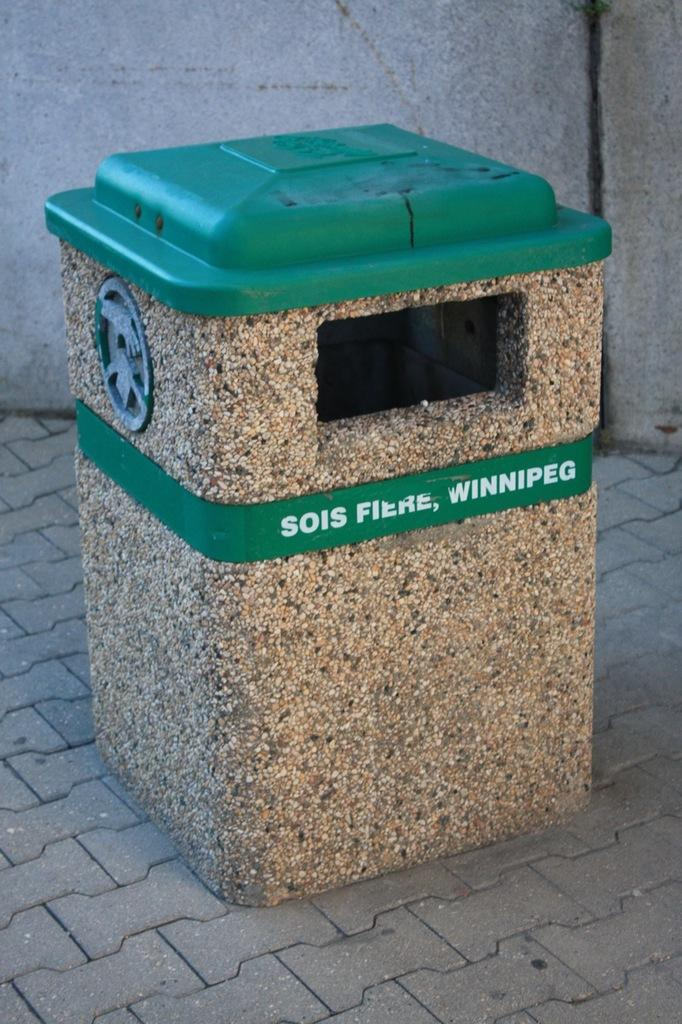<image>
Share a concise interpretation of the image provided. A trash bin has the word Sois Fiere on it as well as Winnipeg. 